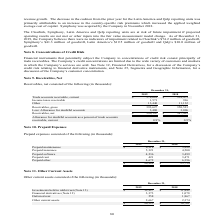According to Sykes Enterprises Incorporated's financial document, What was the amount for Other in 2019? According to the financial document, 13,440 (in thousands). The relevant text states: "Other 13,440 11,132..." Also, What was the amount for  Receivables, gross in 2018? According to the financial document, 350,521 (in thousands). The relevant text states: "Receivables, gross 393,627 350,521..." Also, In which years is the amount of Receivables, net calculated? The document shows two values: 2019 and 2018. From the document: "2019 2018 2019 2018..." Additionally, In which year was the amount of Less: Allowance for doubtful accounts larger? According to the financial document, 2019. The relevant text states: "2019 2018..." Also, can you calculate: What was the change in Income taxes receivable in 2019 from 2018? Based on the calculation: 1,571-916, the result is 655 (in thousands). This is based on the information: "Income taxes receivable 1,571 916 Income taxes receivable 1,571 916..." The key data points involved are: 1,571, 916. Also, can you calculate: What was the percentage change in Income taxes receivable in 2019 from 2018? To answer this question, I need to perform calculations using the financial data. The calculation is: (1,571-916)/916, which equals 71.51 (percentage). This is based on the information: "Income taxes receivable 1,571 916 Income taxes receivable 1,571 916..." The key data points involved are: 1,571, 916. 